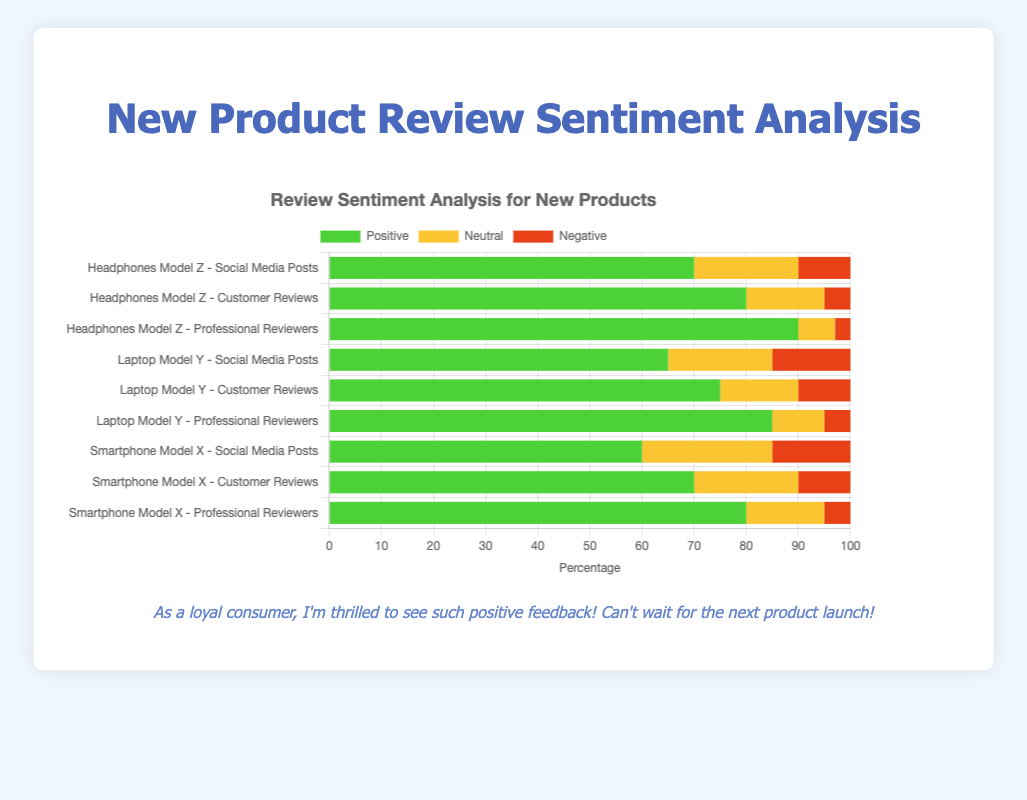Which product has the highest percentage of positive reviews from professional reviewers? Headphones Model Z has the highest positive reviews from professional reviewers. The figure shows the green bar for "Headphones Model Z - Professional Reviewers" is the longest among the positive review sections.
Answer: Headphones Model Z Compare the negative reviews from social media posts between Smartphone Model X and Laptop Model Y. Which one has more negative feedback? By looking at the red bars for "Smartphone Model X - Social Media Posts" and "Laptop Model Y - Social Media Posts," we see that both have the same length, indicating equal negative reviews.
Answer: Equal What's the combined percentage of neutral and negative reviews for Headphones Model Z from customer reviews? For Headphones Model Z - Customer Reviews, the neutral reviews are 15%, and the negative reviews are 5%. Adding these gives 15% + 5% = 20%.
Answer: 20% Which source shows the most significant difference in positive reviews between Smartphone Model X and Laptop Model Y? Compare the lengths of the green bars for Smartphone Model X and Laptop Model Y across all sources. The difference is greatest for professional reviewers (80% vs. 85%), a 5% difference.
Answer: Professional reviewers Among all sources for Laptop Model Y, which sentiment category shows the lowest percentage? By examining all review sources for Laptop Model Y, the red (negative) section for "Laptop Model Y - Professional Reviewers" at 5% is the shortest.
Answer: Negative for professional reviewers Compare the positive reviews from customer reviews for Headphones Model Z and Smartphone Model X. Which has a higher percentage? The green bar for "Headphones Model Z - Customer Reviews" is longer at 80%, compared to 70% for "Smartphone Model X - Customer Reviews".
Answer: Headphones Model Z Which product has the least amount of neutral feedback overall? Summing neutral feedback across all sources for each product: Smartphone Model X (15+20+25 = 60%), Laptop Model Y (10+15+20 = 45%), and Headphones Model Z (7+15+20 = 42%). Headphones Model Z has the lowest combined neutral feedback at 42%.
Answer: Headphones Model Z 